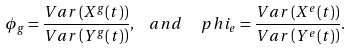<formula> <loc_0><loc_0><loc_500><loc_500>\phi _ { g } = \frac { V a r \left ( X ^ { g } ( t ) \right ) } { V a r \left ( Y ^ { g } ( t ) \right ) } , \ \ a n d \ \ \ p h i _ { e } = \frac { V a r \left ( X ^ { e } ( t ) \right ) } { V a r \left ( Y ^ { e } ( t ) \right ) } .</formula> 